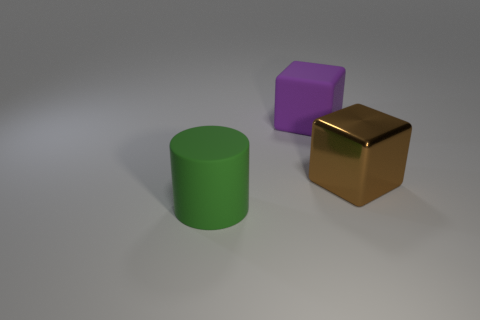In terms of visual balance, how do the objects in the image contribute to the overall composition? The objects in the image create a visual balance through their arrangement and the contrasting sizes and shapes. The green cylinder, purple block, and brown cube contrast in color and form, creating a dynamic yet harmonious composition. 